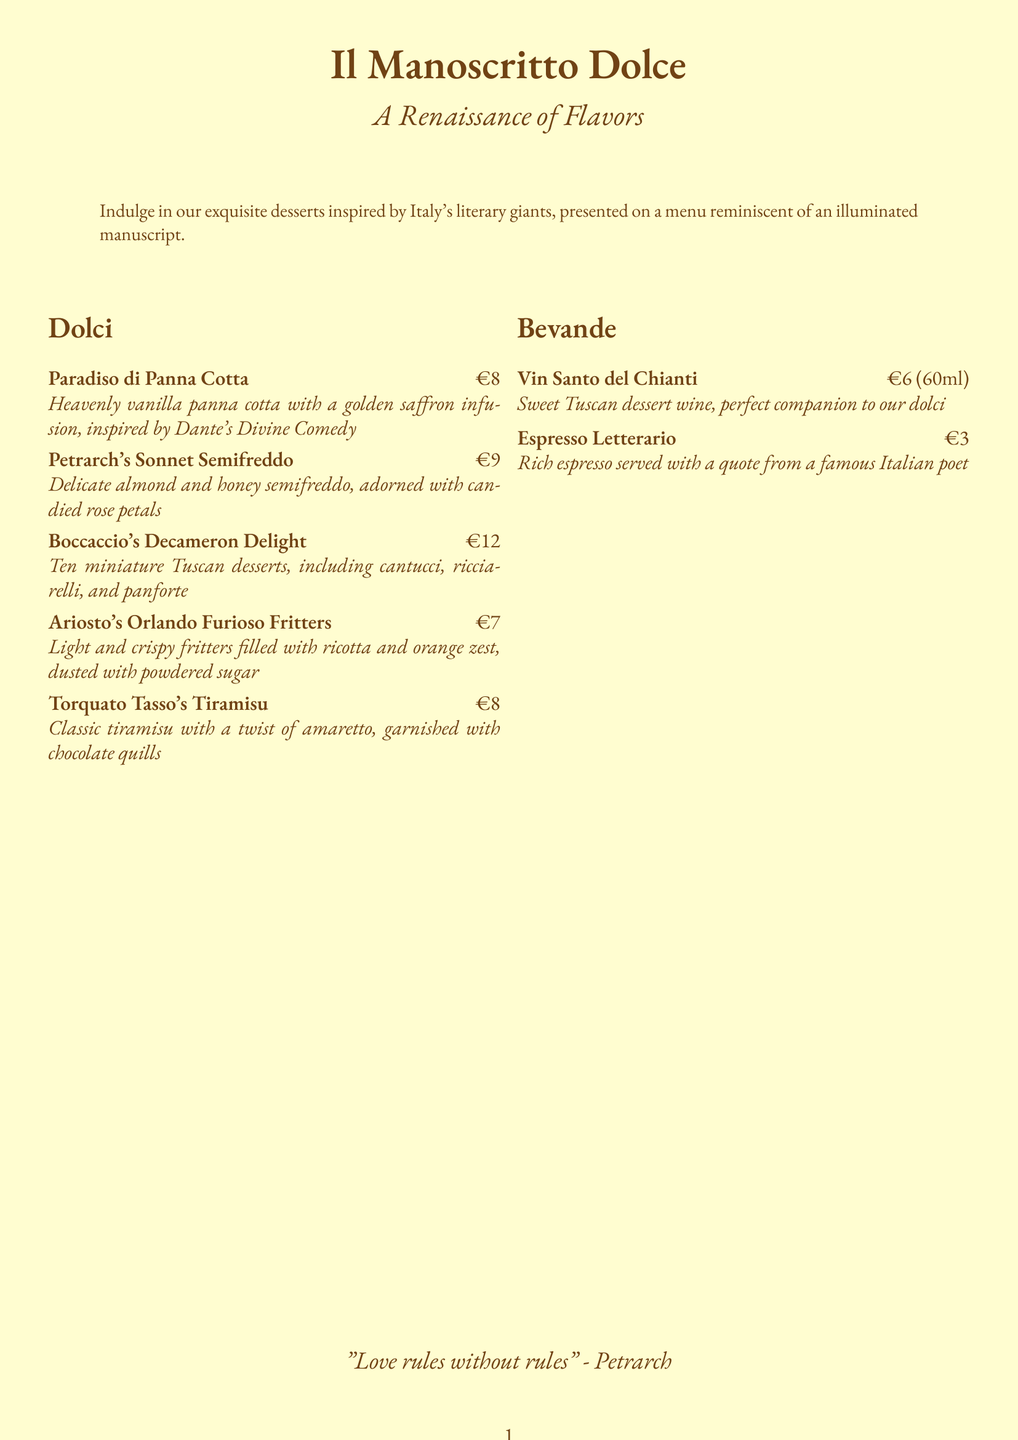What is the name of the dessert inspired by Dante's work? The dessert inspired by Dante's work is called "Paradiso di Panna Cotta."
Answer: Paradiso di Panna Cotta How many miniature Tuscan desserts are included in Boccaccio's dish? Boccaccio's dish includes ten miniature Tuscan desserts.
Answer: Ten What is the price of the Petrarch's Sonnet Semifreddo? The price of Petrarch's Sonnet Semifreddo is stated as €9.
Answer: €9 Which dessert is described as having a saffron infusion? The dessert described as having a saffron infusion is "Paradiso di Panna Cotta."
Answer: Paradiso di Panna Cotta What is the price of the Vin Santo del Chianti? The price of the Vin Santo del Chianti is €6 for a 60ml serving.
Answer: €6 (60ml) What literary figure inspired the Tiramisu on the menu? The Tiramisu on the menu is inspired by Torquato Tasso.
Answer: Torquato Tasso Which beverage is served with a quote from a famous Italian poet? The beverage served with a quote from a famous Italian poet is "Espresso Letterario."
Answer: Espresso Letterario What is the main flavor of the Ariosto's dessert? The main flavor of Ariosto's dessert is filled with ricotta and orange zest.
Answer: Ricotta and orange zest What is the theme of the dessert menu? The theme of the dessert menu is inspired by Italy's literary giants and presented as an illuminated manuscript.
Answer: A Renaissance of Flavors 